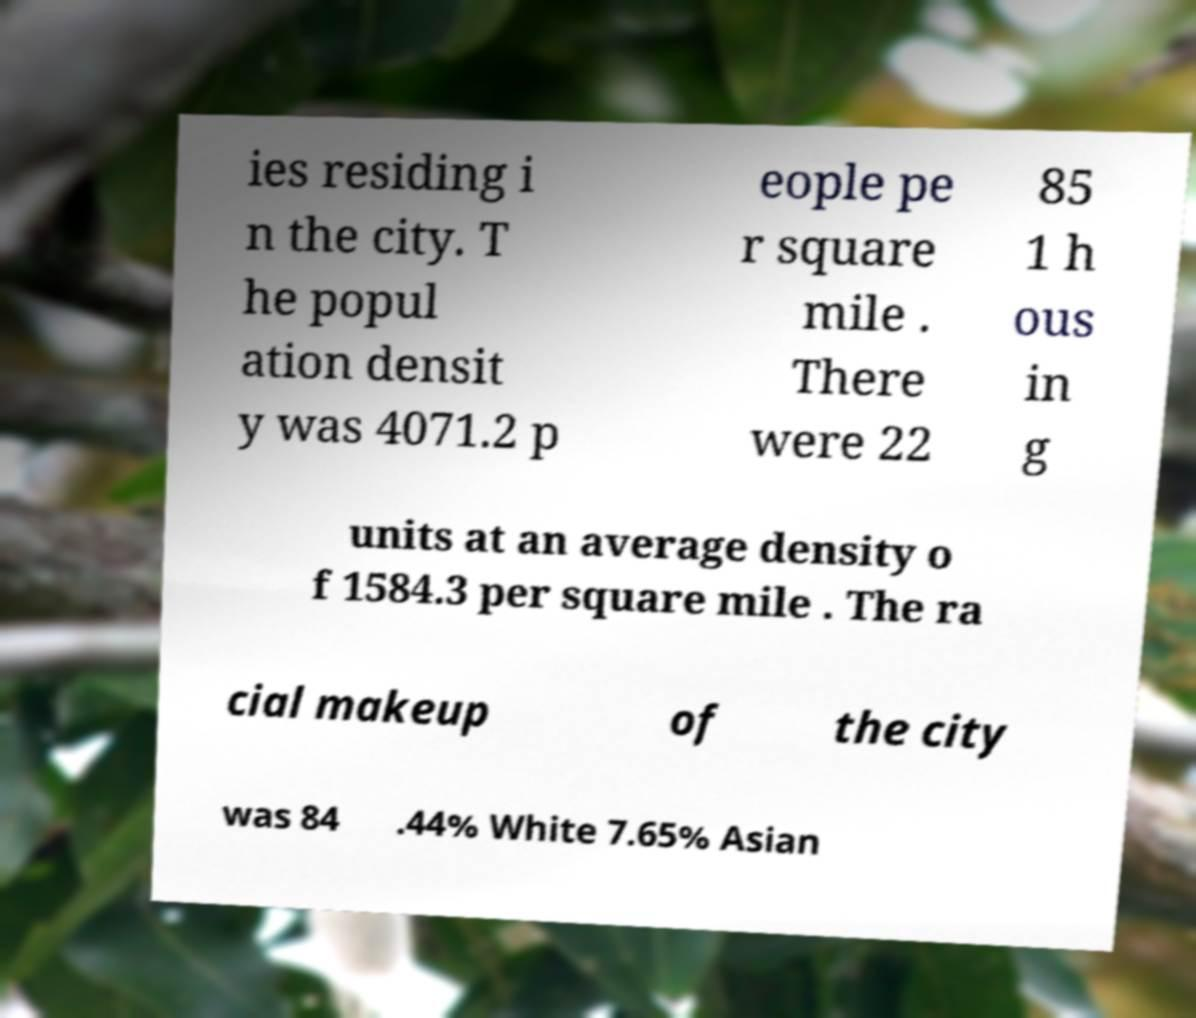Please identify and transcribe the text found in this image. ies residing i n the city. T he popul ation densit y was 4071.2 p eople pe r square mile . There were 22 85 1 h ous in g units at an average density o f 1584.3 per square mile . The ra cial makeup of the city was 84 .44% White 7.65% Asian 